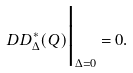Convert formula to latex. <formula><loc_0><loc_0><loc_500><loc_500>\ D D _ { \Delta } ^ { * } ( Q ) \Big | _ { \Delta = 0 } = 0 .</formula> 